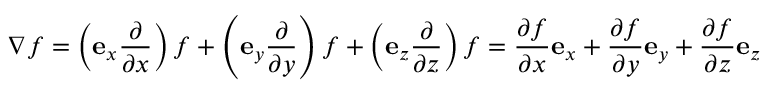Convert formula to latex. <formula><loc_0><loc_0><loc_500><loc_500>\nabla f = \left ( e _ { x } { \frac { \partial } { \partial x } } \right ) f + \left ( e _ { y } { \frac { \partial } { \partial y } } \right ) f + \left ( e _ { z } { \frac { \partial } { \partial z } } \right ) f = { \frac { \partial f } { \partial x } } e _ { x } + { \frac { \partial f } { \partial y } } e _ { y } + { \frac { \partial f } { \partial z } } e _ { z }</formula> 